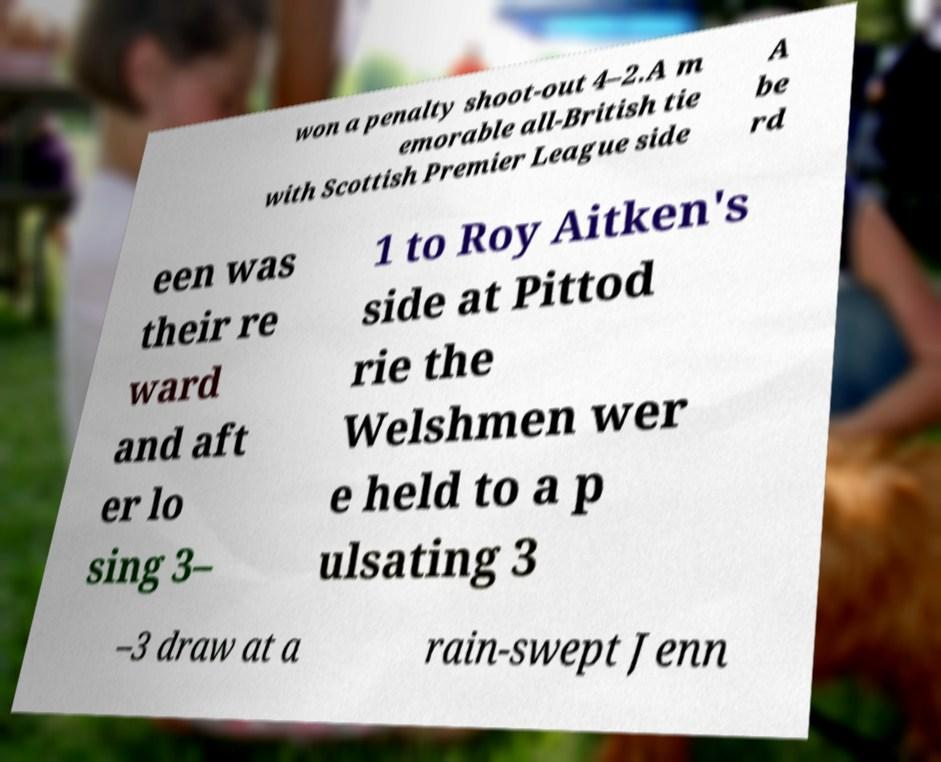Can you accurately transcribe the text from the provided image for me? won a penalty shoot-out 4–2.A m emorable all-British tie with Scottish Premier League side A be rd een was their re ward and aft er lo sing 3– 1 to Roy Aitken's side at Pittod rie the Welshmen wer e held to a p ulsating 3 –3 draw at a rain-swept Jenn 